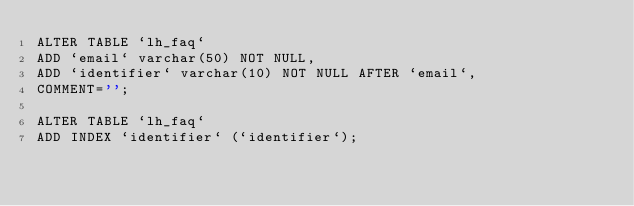Convert code to text. <code><loc_0><loc_0><loc_500><loc_500><_SQL_>ALTER TABLE `lh_faq`
ADD `email` varchar(50) NOT NULL,
ADD `identifier` varchar(10) NOT NULL AFTER `email`,
COMMENT='';

ALTER TABLE `lh_faq`
ADD INDEX `identifier` (`identifier`);</code> 